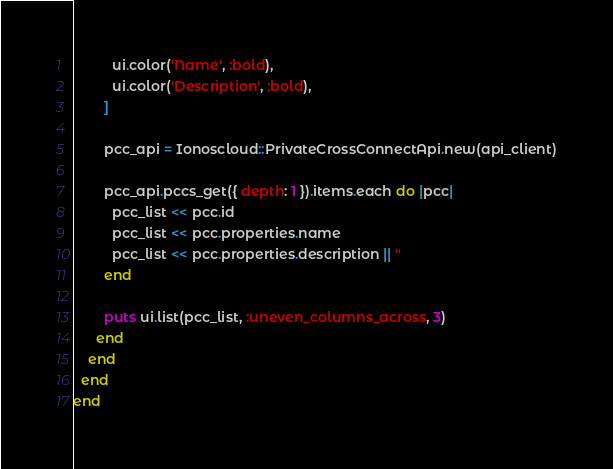<code> <loc_0><loc_0><loc_500><loc_500><_Ruby_>          ui.color('Name', :bold),
          ui.color('Description', :bold),
        ]

        pcc_api = Ionoscloud::PrivateCrossConnectApi.new(api_client)

        pcc_api.pccs_get({ depth: 1 }).items.each do |pcc|
          pcc_list << pcc.id
          pcc_list << pcc.properties.name
          pcc_list << pcc.properties.description || ''
        end

        puts ui.list(pcc_list, :uneven_columns_across, 3)
      end
    end
  end
end
</code> 